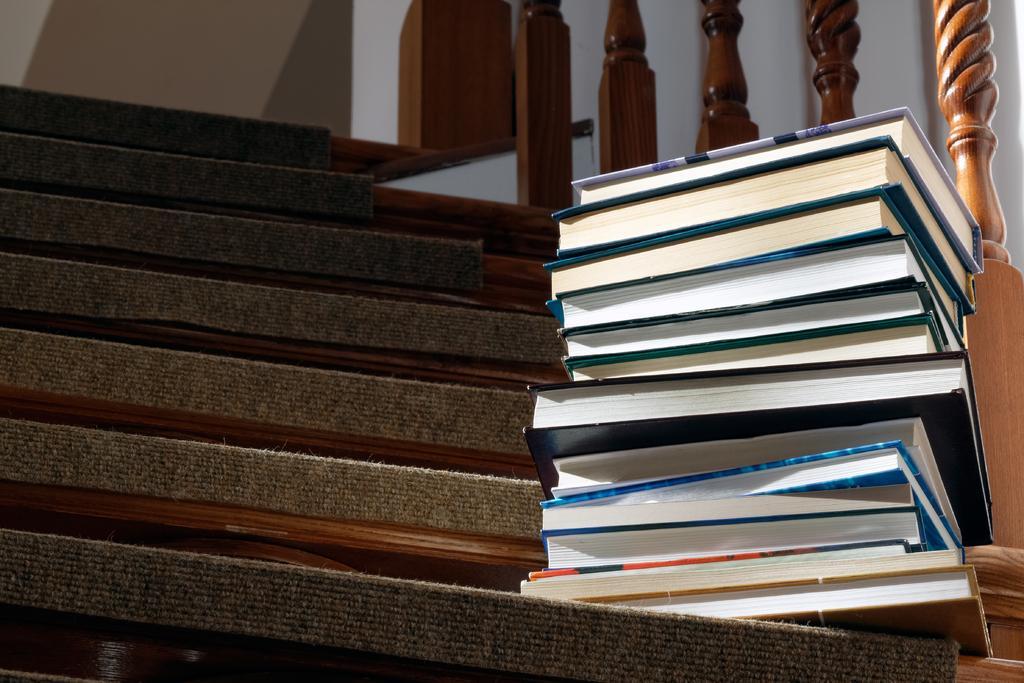Could you give a brief overview of what you see in this image? In this image I can see the books on the stairs. To the right I can see the railing and the wall. 